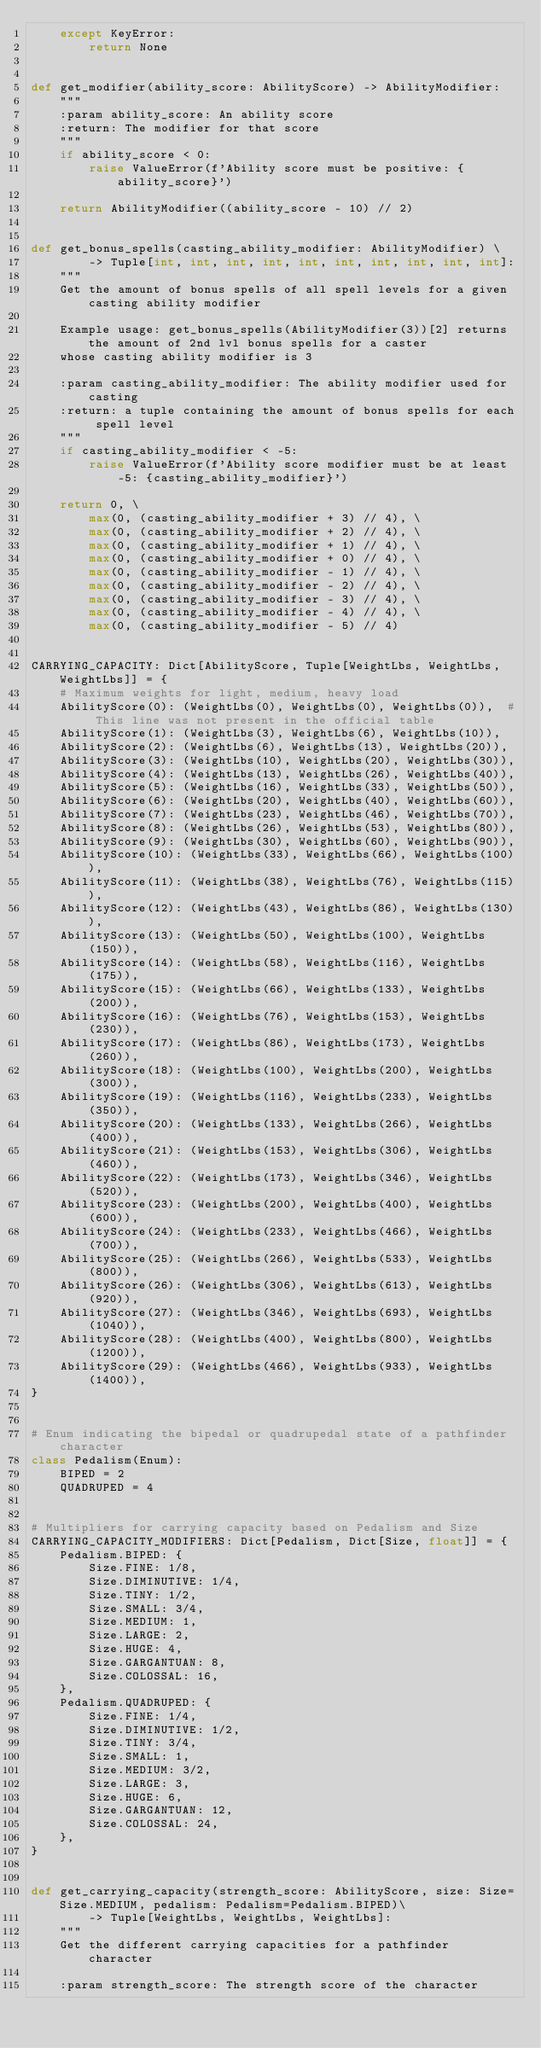<code> <loc_0><loc_0><loc_500><loc_500><_Python_>    except KeyError:
        return None


def get_modifier(ability_score: AbilityScore) -> AbilityModifier:
    """
    :param ability_score: An ability score
    :return: The modifier for that score
    """
    if ability_score < 0:
        raise ValueError(f'Ability score must be positive: {ability_score}')

    return AbilityModifier((ability_score - 10) // 2)


def get_bonus_spells(casting_ability_modifier: AbilityModifier) \
        -> Tuple[int, int, int, int, int, int, int, int, int, int]:
    """
    Get the amount of bonus spells of all spell levels for a given casting ability modifier

    Example usage: get_bonus_spells(AbilityModifier(3))[2] returns the amount of 2nd lvl bonus spells for a caster
    whose casting ability modifier is 3

    :param casting_ability_modifier: The ability modifier used for casting
    :return: a tuple containing the amount of bonus spells for each spell level
    """
    if casting_ability_modifier < -5:
        raise ValueError(f'Ability score modifier must be at least -5: {casting_ability_modifier}')

    return 0, \
        max(0, (casting_ability_modifier + 3) // 4), \
        max(0, (casting_ability_modifier + 2) // 4), \
        max(0, (casting_ability_modifier + 1) // 4), \
        max(0, (casting_ability_modifier + 0) // 4), \
        max(0, (casting_ability_modifier - 1) // 4), \
        max(0, (casting_ability_modifier - 2) // 4), \
        max(0, (casting_ability_modifier - 3) // 4), \
        max(0, (casting_ability_modifier - 4) // 4), \
        max(0, (casting_ability_modifier - 5) // 4)


CARRYING_CAPACITY: Dict[AbilityScore, Tuple[WeightLbs, WeightLbs, WeightLbs]] = {
    # Maximum weights for light, medium, heavy load
    AbilityScore(0): (WeightLbs(0), WeightLbs(0), WeightLbs(0)),  # This line was not present in the official table
    AbilityScore(1): (WeightLbs(3), WeightLbs(6), WeightLbs(10)),
    AbilityScore(2): (WeightLbs(6), WeightLbs(13), WeightLbs(20)),
    AbilityScore(3): (WeightLbs(10), WeightLbs(20), WeightLbs(30)),
    AbilityScore(4): (WeightLbs(13), WeightLbs(26), WeightLbs(40)),
    AbilityScore(5): (WeightLbs(16), WeightLbs(33), WeightLbs(50)),
    AbilityScore(6): (WeightLbs(20), WeightLbs(40), WeightLbs(60)),
    AbilityScore(7): (WeightLbs(23), WeightLbs(46), WeightLbs(70)),
    AbilityScore(8): (WeightLbs(26), WeightLbs(53), WeightLbs(80)),
    AbilityScore(9): (WeightLbs(30), WeightLbs(60), WeightLbs(90)),
    AbilityScore(10): (WeightLbs(33), WeightLbs(66), WeightLbs(100)),
    AbilityScore(11): (WeightLbs(38), WeightLbs(76), WeightLbs(115)),
    AbilityScore(12): (WeightLbs(43), WeightLbs(86), WeightLbs(130)),
    AbilityScore(13): (WeightLbs(50), WeightLbs(100), WeightLbs(150)),
    AbilityScore(14): (WeightLbs(58), WeightLbs(116), WeightLbs(175)),
    AbilityScore(15): (WeightLbs(66), WeightLbs(133), WeightLbs(200)),
    AbilityScore(16): (WeightLbs(76), WeightLbs(153), WeightLbs(230)),
    AbilityScore(17): (WeightLbs(86), WeightLbs(173), WeightLbs(260)),
    AbilityScore(18): (WeightLbs(100), WeightLbs(200), WeightLbs(300)),
    AbilityScore(19): (WeightLbs(116), WeightLbs(233), WeightLbs(350)),
    AbilityScore(20): (WeightLbs(133), WeightLbs(266), WeightLbs(400)),
    AbilityScore(21): (WeightLbs(153), WeightLbs(306), WeightLbs(460)),
    AbilityScore(22): (WeightLbs(173), WeightLbs(346), WeightLbs(520)),
    AbilityScore(23): (WeightLbs(200), WeightLbs(400), WeightLbs(600)),
    AbilityScore(24): (WeightLbs(233), WeightLbs(466), WeightLbs(700)),
    AbilityScore(25): (WeightLbs(266), WeightLbs(533), WeightLbs(800)),
    AbilityScore(26): (WeightLbs(306), WeightLbs(613), WeightLbs(920)),
    AbilityScore(27): (WeightLbs(346), WeightLbs(693), WeightLbs(1040)),
    AbilityScore(28): (WeightLbs(400), WeightLbs(800), WeightLbs(1200)),
    AbilityScore(29): (WeightLbs(466), WeightLbs(933), WeightLbs(1400)),
}


# Enum indicating the bipedal or quadrupedal state of a pathfinder character
class Pedalism(Enum):
    BIPED = 2
    QUADRUPED = 4


# Multipliers for carrying capacity based on Pedalism and Size
CARRYING_CAPACITY_MODIFIERS: Dict[Pedalism, Dict[Size, float]] = {
    Pedalism.BIPED: {
        Size.FINE: 1/8,
        Size.DIMINUTIVE: 1/4,
        Size.TINY: 1/2,
        Size.SMALL: 3/4,
        Size.MEDIUM: 1,
        Size.LARGE: 2,
        Size.HUGE: 4,
        Size.GARGANTUAN: 8,
        Size.COLOSSAL: 16,
    },
    Pedalism.QUADRUPED: {
        Size.FINE: 1/4,
        Size.DIMINUTIVE: 1/2,
        Size.TINY: 3/4,
        Size.SMALL: 1,
        Size.MEDIUM: 3/2,
        Size.LARGE: 3,
        Size.HUGE: 6,
        Size.GARGANTUAN: 12,
        Size.COLOSSAL: 24,
    },
}


def get_carrying_capacity(strength_score: AbilityScore, size: Size=Size.MEDIUM, pedalism: Pedalism=Pedalism.BIPED)\
        -> Tuple[WeightLbs, WeightLbs, WeightLbs]:
    """
    Get the different carrying capacities for a pathfinder character

    :param strength_score: The strength score of the character</code> 